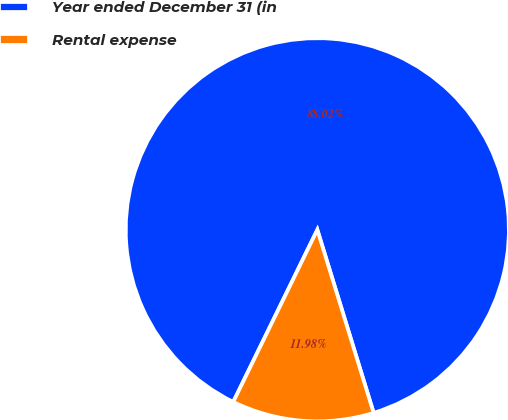<chart> <loc_0><loc_0><loc_500><loc_500><pie_chart><fcel>Year ended December 31 (in<fcel>Rental expense<nl><fcel>88.02%<fcel>11.98%<nl></chart> 